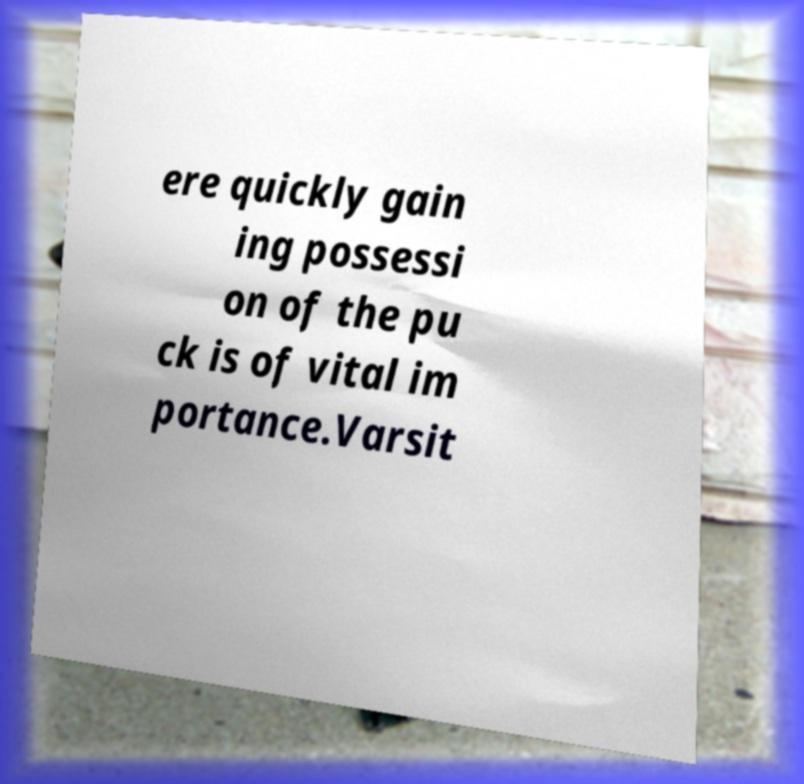Can you read and provide the text displayed in the image?This photo seems to have some interesting text. Can you extract and type it out for me? ere quickly gain ing possessi on of the pu ck is of vital im portance.Varsit 